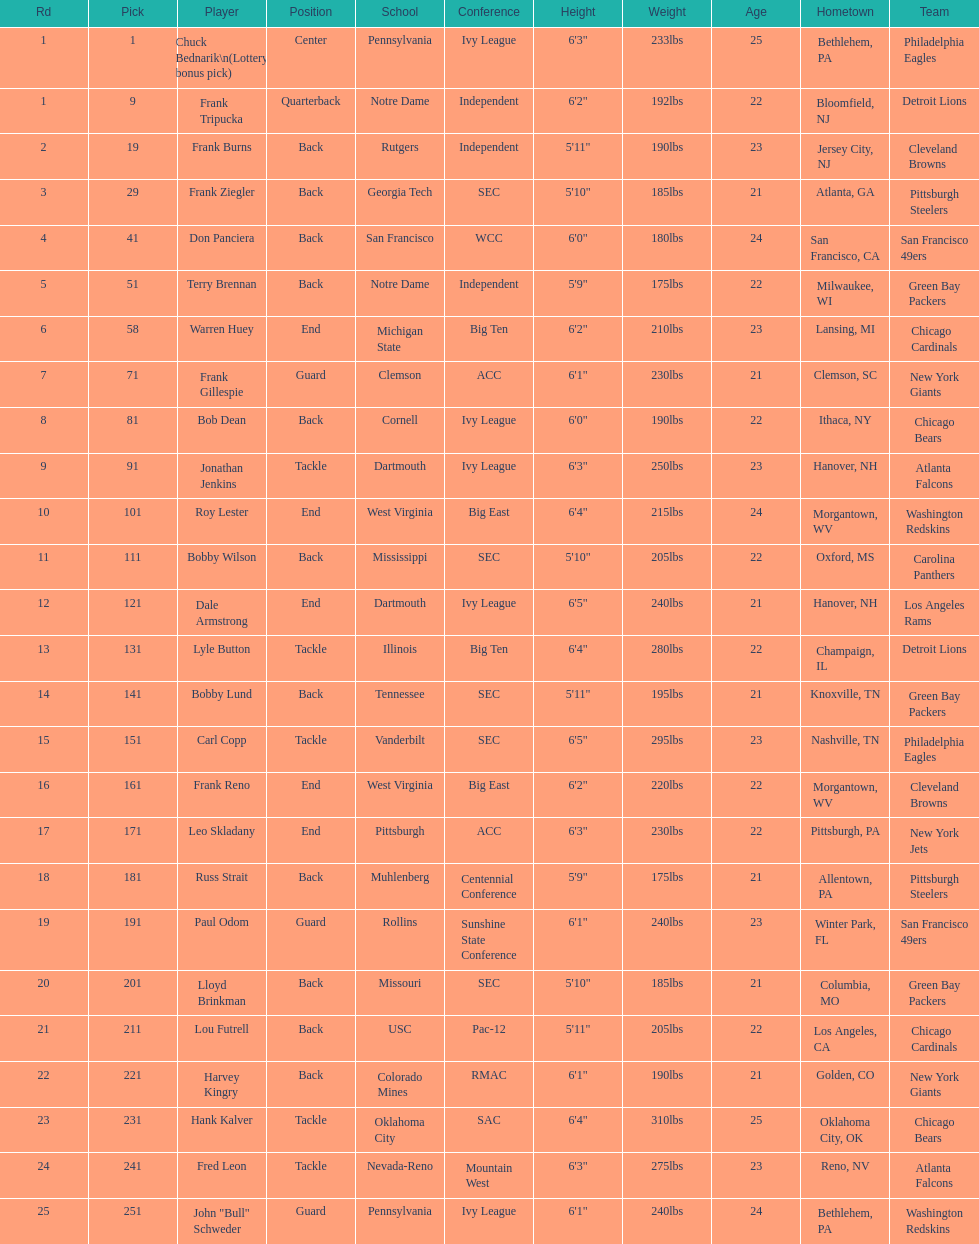What is the most common school type? Pennsylvania. 